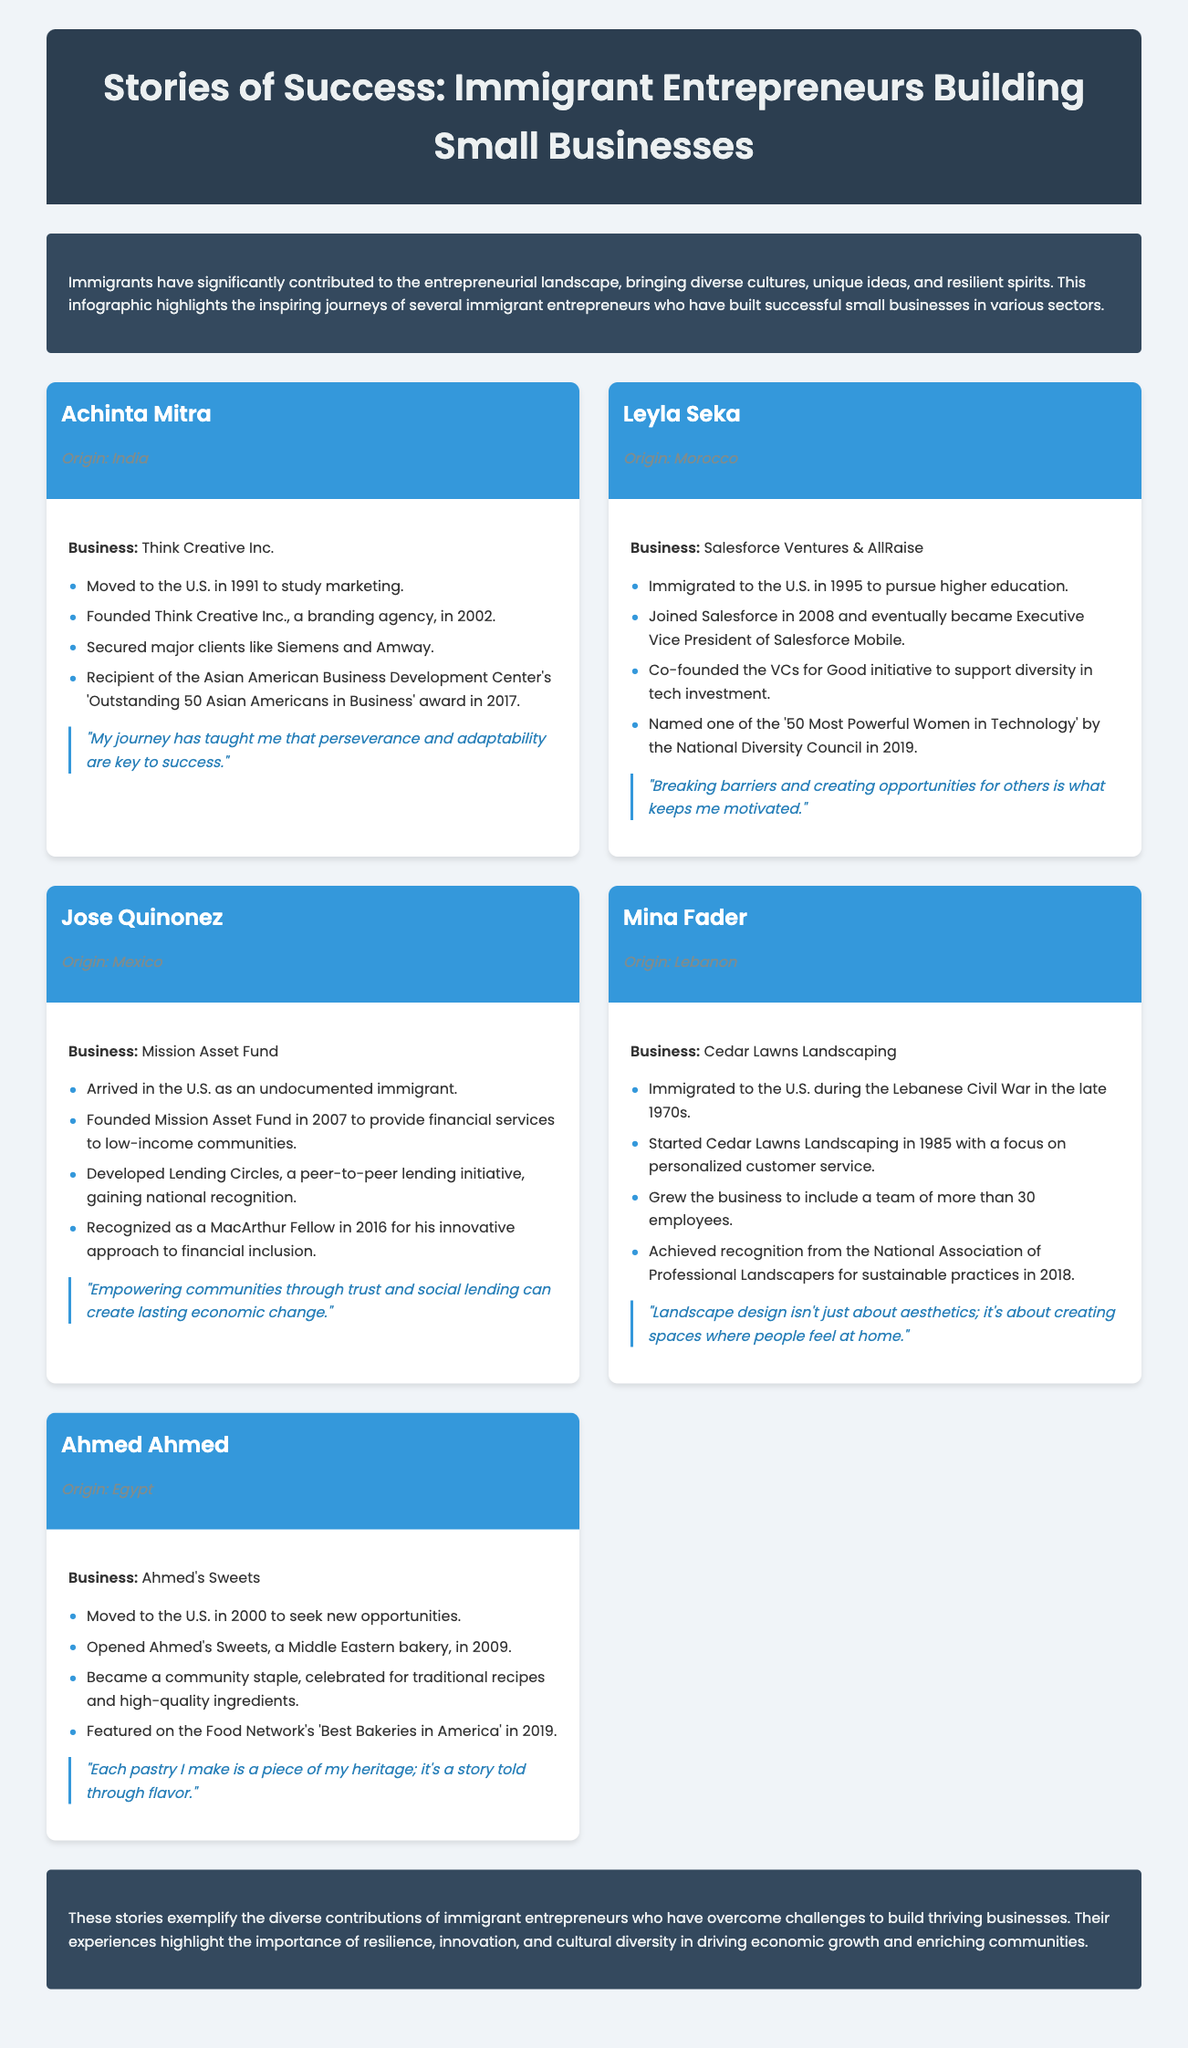What is the title of the infographic? The title is clearly stated at the top of the document, identifying the focus of the infographic on immigrant entrepreneurs.
Answer: Stories of Success: Immigrant Entrepreneurs Building Small Businesses Who is the entrepreneur from India? The document provides specific names of entrepreneurs along with their origins, making it straightforward to retrieve this information.
Answer: Achinta Mitra What year was Think Creative Inc. founded? The founding year of businesses is listed under each entrepreneur's milestones, allowing for easy identification of this date.
Answer: 2002 How many employees does Cedar Lawns Landscaping have? This information is included in the milestones, indicating the scale of the business regarding its workforce.
Answer: More than 30 Which award did Leyla Seka receive in 2019? The document highlights different awards received by the entrepreneurs and the corresponding years, making this information accessible.
Answer: 50 Most Powerful Women in Technology What is Jose Quinonez recognized as in 2016? This recognition is specifically noted among the achievements listed for Jose Quinonez, summarizing his contributions effectively.
Answer: MacArthur Fellow What type of business does Ahmed's Sweets operate? The document explicitly states the type of business for each entrepreneur, providing direct insight into their entrepreneurial ventures.
Answer: Middle Eastern bakery What is the main focus of the infographic? The introduction summarizes the overall aim and thematic focus of the infographic, clarifying the content's purpose.
Answer: Inspiring journeys of immigrant entrepreneurs What product did Ahmed Ahmed become celebrated for? The document explicitly mentions what Ahmed Ahmed is known for, connecting his business to community recognition.
Answer: Traditional recipes 